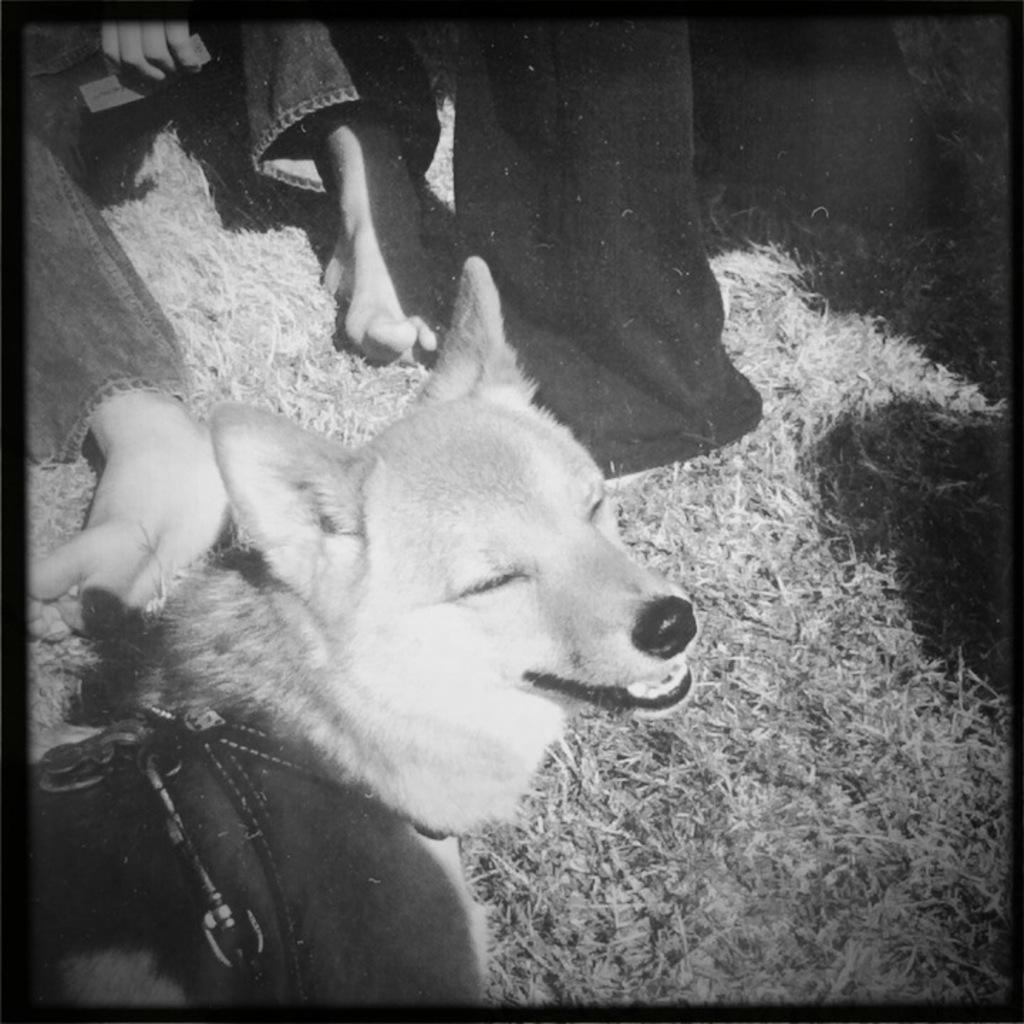What is the color scheme of the image? The image is black and white. What can be seen in the middle of the image? There are legs of a person and a dog in the middle of the image. What type of surface is visible in the image? There is grass visible in the image. What is the name of the dog in the image? There is no information about the dog's name in the image. Is there a recess or camp visible in the image? There is no recess or camp present in the image; it features a person's legs and a dog on a grassy surface. 